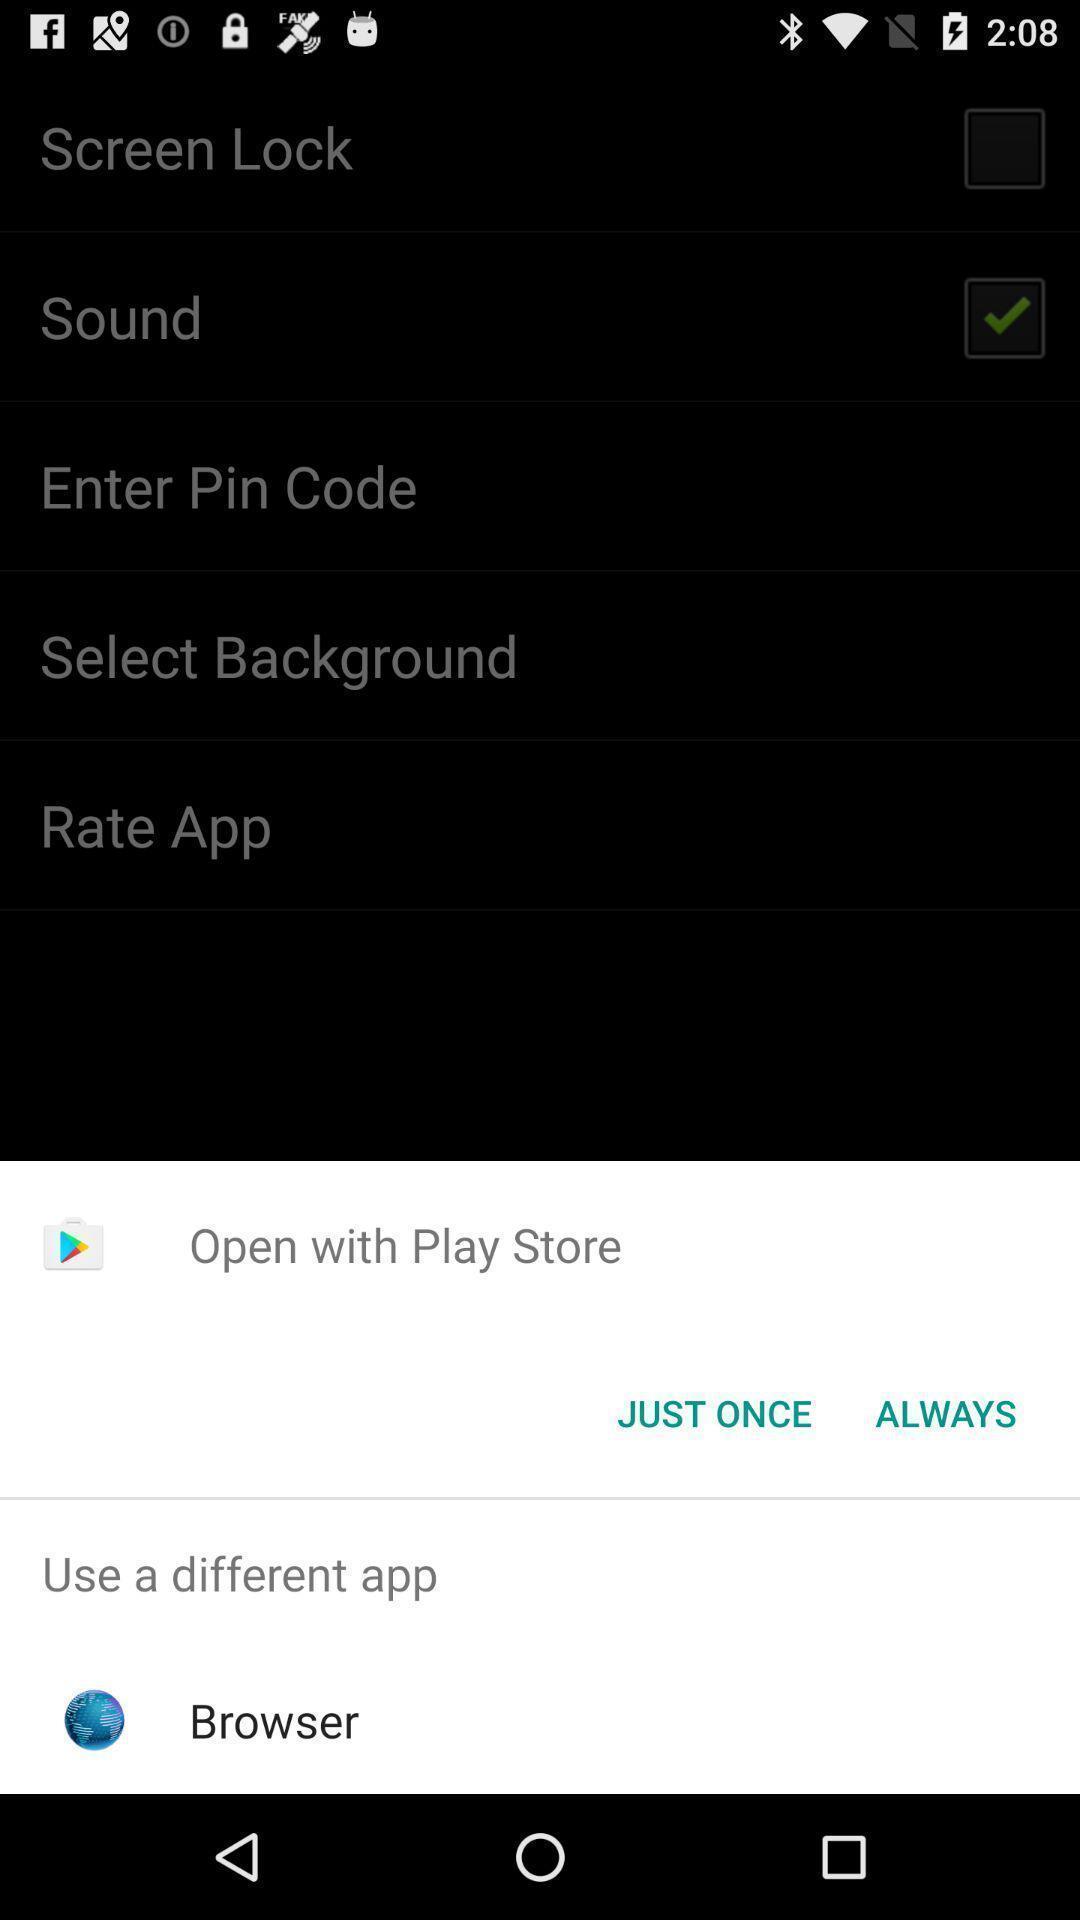Tell me what you see in this picture. Popup showing options to choose. 